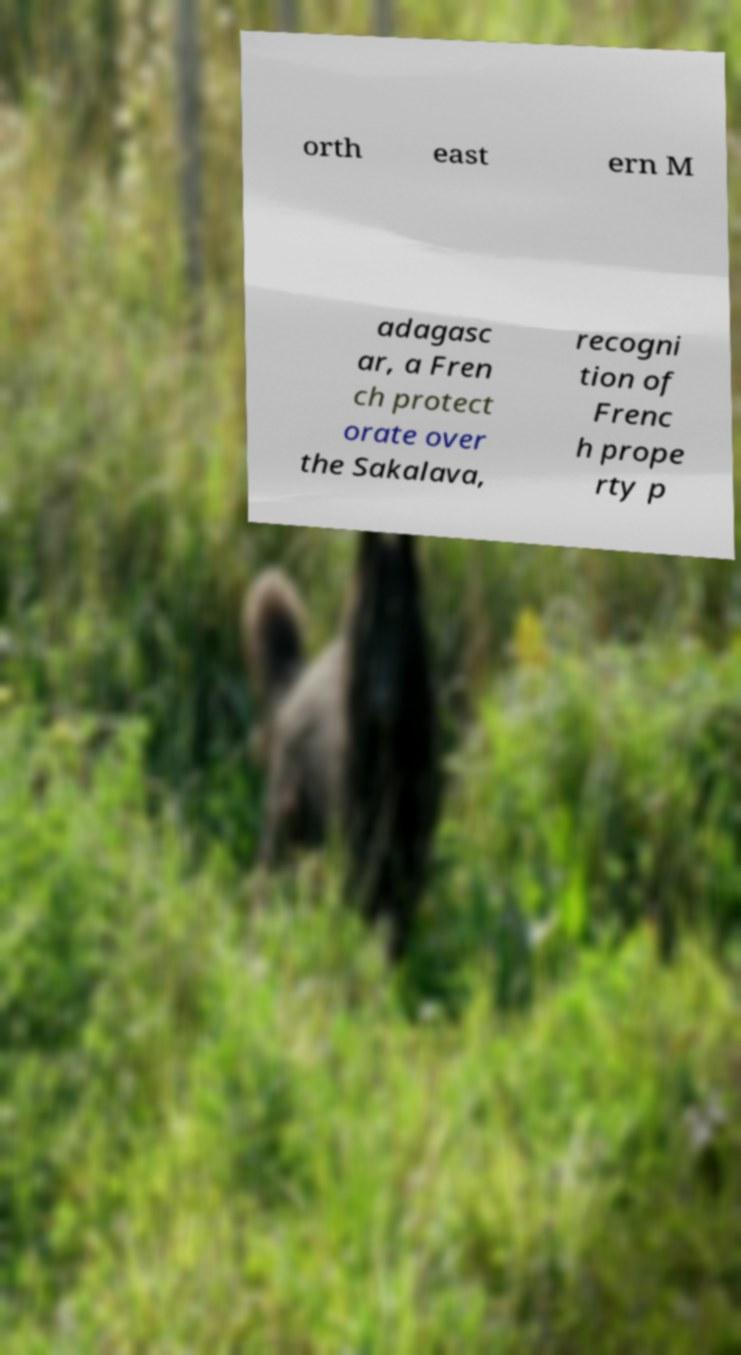Could you extract and type out the text from this image? orth east ern M adagasc ar, a Fren ch protect orate over the Sakalava, recogni tion of Frenc h prope rty p 